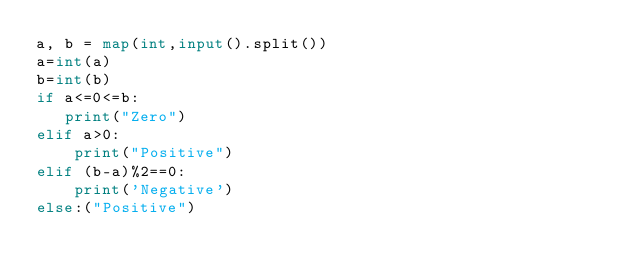Convert code to text. <code><loc_0><loc_0><loc_500><loc_500><_Python_>a, b = map(int,input().split())
a=int(a)
b=int(b)
if a<=0<=b:
   print("Zero")
elif a>0:
    print("Positive")
elif (b-a)%2==0:
    print('Negative')
else:("Positive")</code> 